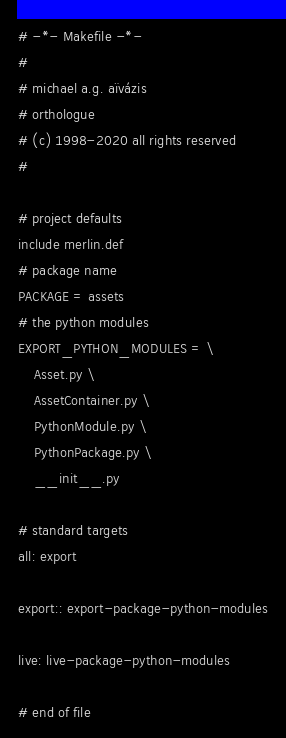Convert code to text. <code><loc_0><loc_0><loc_500><loc_500><_ObjectiveC_># -*- Makefile -*-
#
# michael a.g. aïvázis
# orthologue
# (c) 1998-2020 all rights reserved
#

# project defaults
include merlin.def
# package name
PACKAGE = assets
# the python modules
EXPORT_PYTHON_MODULES = \
    Asset.py \
    AssetContainer.py \
    PythonModule.py \
    PythonPackage.py \
    __init__.py

# standard targets
all: export

export:: export-package-python-modules

live: live-package-python-modules

# end of file
</code> 